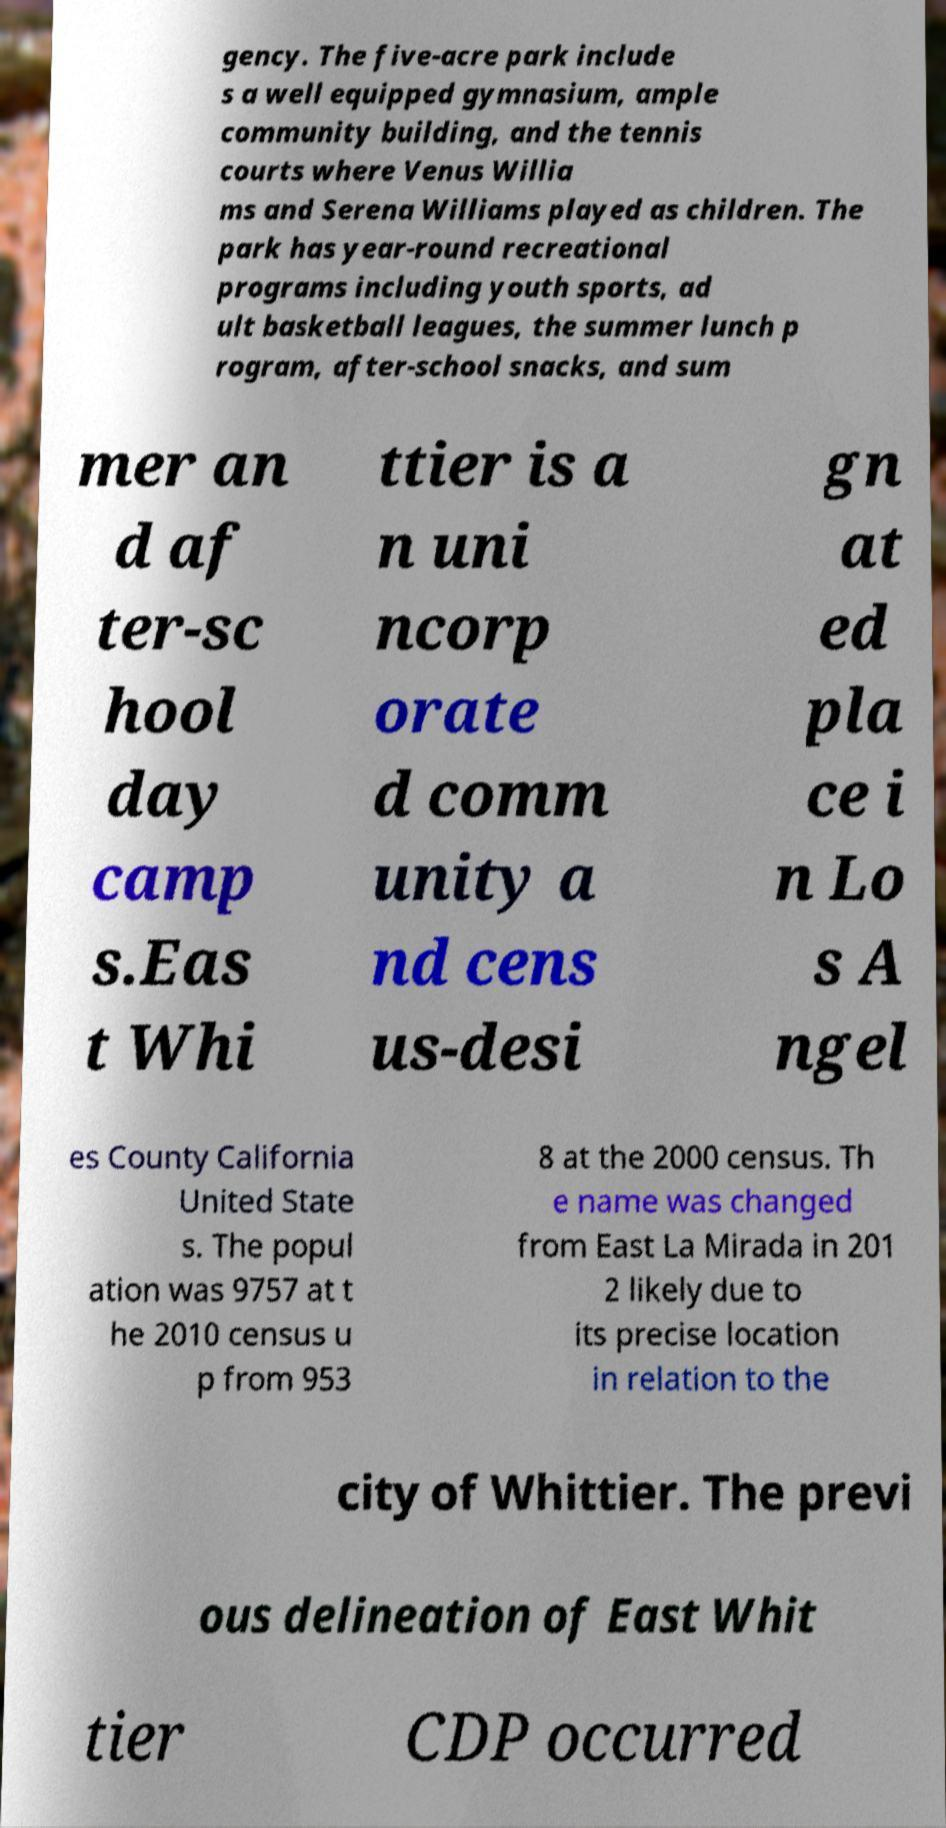Can you read and provide the text displayed in the image?This photo seems to have some interesting text. Can you extract and type it out for me? gency. The five-acre park include s a well equipped gymnasium, ample community building, and the tennis courts where Venus Willia ms and Serena Williams played as children. The park has year-round recreational programs including youth sports, ad ult basketball leagues, the summer lunch p rogram, after-school snacks, and sum mer an d af ter-sc hool day camp s.Eas t Whi ttier is a n uni ncorp orate d comm unity a nd cens us-desi gn at ed pla ce i n Lo s A ngel es County California United State s. The popul ation was 9757 at t he 2010 census u p from 953 8 at the 2000 census. Th e name was changed from East La Mirada in 201 2 likely due to its precise location in relation to the city of Whittier. The previ ous delineation of East Whit tier CDP occurred 